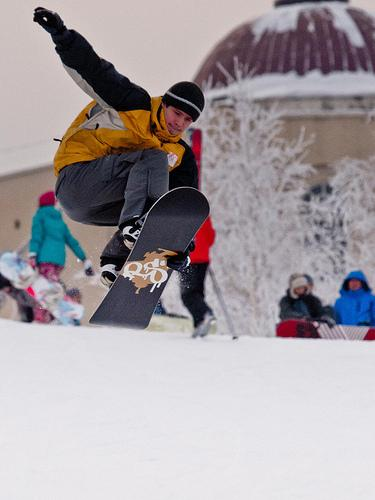List down the clothing items and accessories worn by the woman in the blue jacket. The woman in the blue jacket is wearing a dark pink cap, gray pants, and is carrying a multicolored snowboard. Describe the common color theme of the snow covered trees, and the position they occupy in the image. The snow-covered trees are mostly white with snow and they are in the background of the image. Count the number of people wearing jackets and describe the color of each jacket. There are five people wearing jackets in the image: a man wearing a yellow and black jacket, a woman wearing a blue jacket, a person wearing a green jacket, a person in a red jacket and black pants, and a person wearing a hooded blue jacket. Identify the dominant colors in the snowboards visible in the image. The dominant colors in the snowboards are black, red, and white. What are the surrounding objects in the image besides the main snowboarding action? There are snow-covered trees, people watching and holding snowboards in the background, a red dome over a tan building, and a woman wearing a pink hat and pants. Identify the clothing and gear worn by the primary snowboarder in the image. The primary snowboarder is wearing a black snowboard, black pants, a black knit cap with a white stripe, and a yellow and black jacket with a tag on it. What are the building structures in the image, and what are their features? There is a tan building with a large red domed roof in the image. State the type of hat worn by the woman behind the jumper. The woman behind the jumper is wearing a dark pink hat. How many people are holding snowboards in the image, and describe their appearances. There are two people holding snowboards; they are wearing jackets, one with a blue one and another with a green one, and they're standing in the background. Based on the objects and people in the image, describe the overall atmosphere or scene taking place. This is a winter scene with people enjoying snowboarding and skiing activities, watching others perform jumps or tricks, and taking in the natural beauty of snow-covered trees and buildings. What is the dominant emotion conveyed by the image of the snowboarding event? Excitement List all the colors of the snowboards in the image. Black, red with white stripes How would you rate the quality of the image from 1-10, with 10 being the highest? 8 What color is the jacket of the man on the black snowboard? Yellow and black Notice the flying saucer hovering above the red dome over the tan building. No, it's not mentioned in the image. Describe the scene taking place in the image. A snowboarding event with people enjoying the activity, surrounded by snow-covered trees and a building with a red dome. Describe the interactions between the people and snowboards in the image. People are snowboarding, holding snowboards, and watching others snowboard. What text can be found in the image? None Are there any unusual elements in the image? No Find the person in the image wearing a pink hat. Woman, X:29 Y:184, Width:38 Height:38 Find the trees covered with snow in the image. X:192 Y:55, Width:180 Height:180 Is the woman in the blue jacket interacting with the snowboarder in the black hat? No, she is not directly interacting. Determine if the image features any anomalies or unexpected elements. No anomalies found. Detect objects in the image and their locations. man on black snowboard (X:30 Y:5), woman in blue jacket (X:0 Y:189), trees covered in snow (X:192 Y:55), red dome over tan building (X:0 Y:0), snow on the ground (X:0 Y:319) Segment the image based on semantic regions. People, snowboards, trees, snow, building Are there any brand logos visible on the snowboards? Yes, there is a symbol on the black snowboard (X:81 Y:180, Width:132 Height:132) Name the different types of hats worn in the image. Pink hat, black hat with white stripe, black knit cap, dark pink cap, fuschia ski cap. Would someone viewing this image feel included in the snowboarding event? Yes Which of the following descriptions best matches the image: A) A sunny beach day with people swimming, B) A snowboarding event with people in colorful clothing, or C) A city street with cars and pedestrians? B) A snowboarding event with people in colorful clothing Identify the sentiment conveyed by the image. Excitement and enjoyment. 